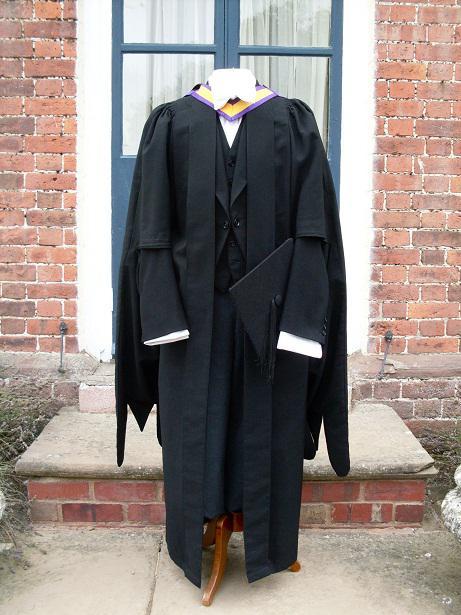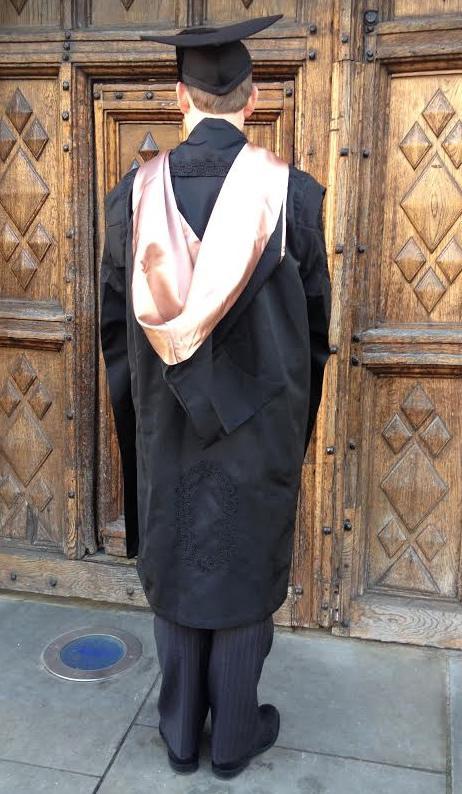The first image is the image on the left, the second image is the image on the right. Analyze the images presented: Is the assertion "One picture shows someone from the back side." valid? Answer yes or no. Yes. The first image is the image on the left, the second image is the image on the right. Examine the images to the left and right. Is the description "a person is facing away from the camera with a light colored sash hanging down their back" accurate? Answer yes or no. Yes. 